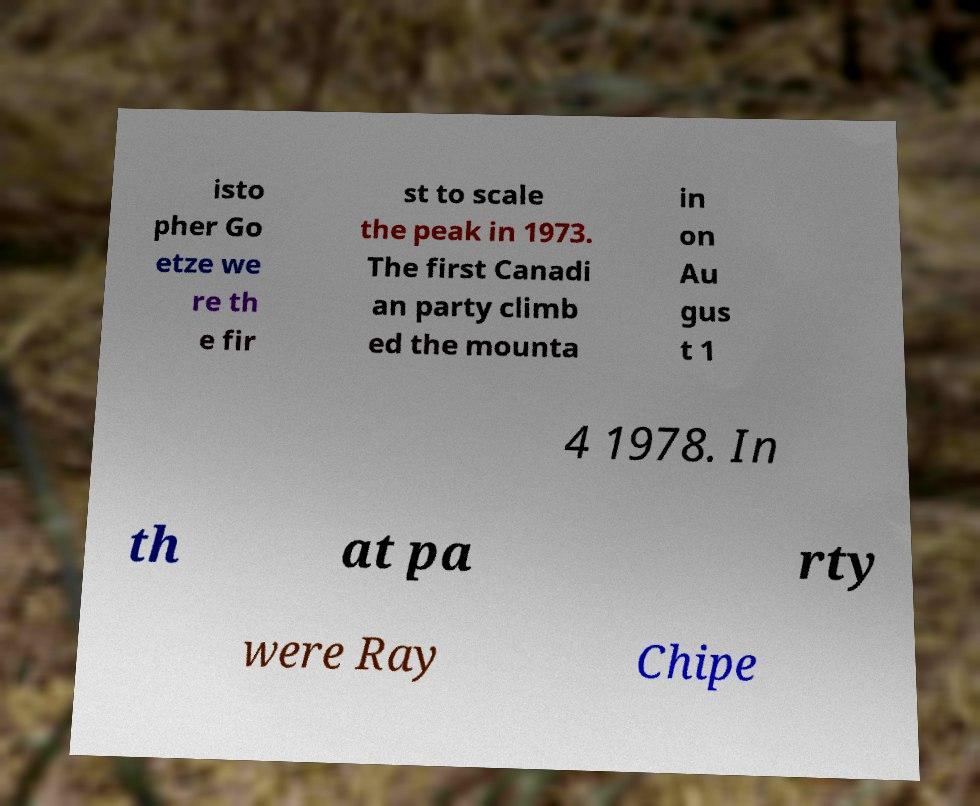Can you read and provide the text displayed in the image?This photo seems to have some interesting text. Can you extract and type it out for me? isto pher Go etze we re th e fir st to scale the peak in 1973. The first Canadi an party climb ed the mounta in on Au gus t 1 4 1978. In th at pa rty were Ray Chipe 